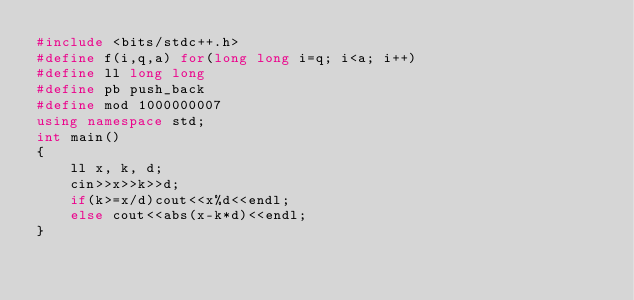<code> <loc_0><loc_0><loc_500><loc_500><_C++_>#include <bits/stdc++.h>
#define f(i,q,a) for(long long i=q; i<a; i++)
#define ll long long
#define pb push_back
#define mod 1000000007
using namespace std;
int main()
{
    ll x, k, d;
    cin>>x>>k>>d;
    if(k>=x/d)cout<<x%d<<endl;
    else cout<<abs(x-k*d)<<endl;
}
</code> 